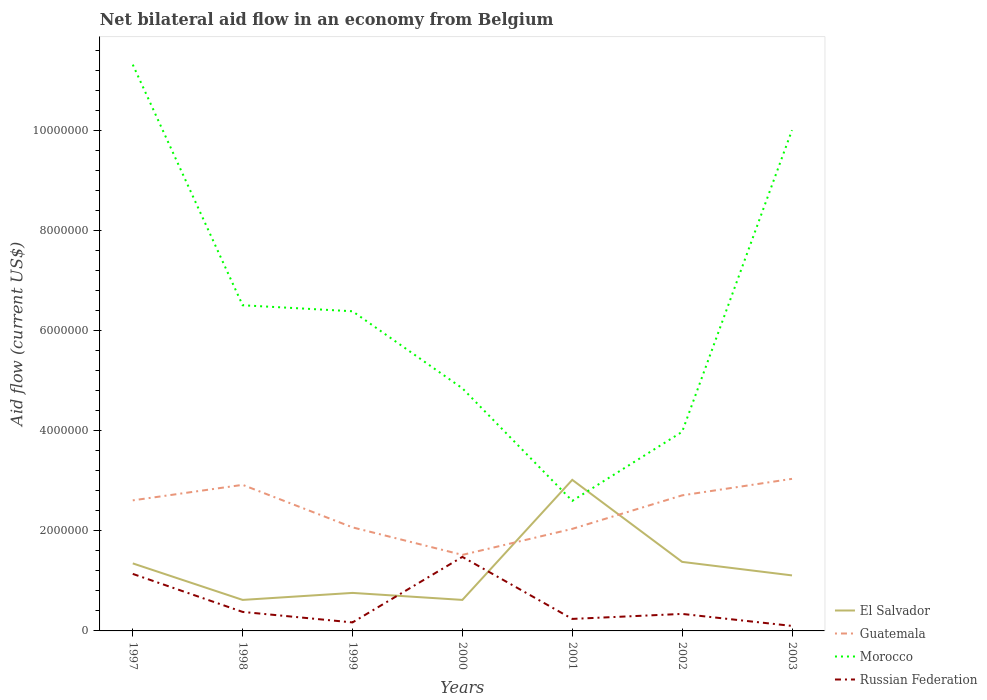Does the line corresponding to El Salvador intersect with the line corresponding to Guatemala?
Give a very brief answer. Yes. Across all years, what is the maximum net bilateral aid flow in El Salvador?
Offer a very short reply. 6.20e+05. What is the total net bilateral aid flow in Morocco in the graph?
Give a very brief answer. 6.47e+06. What is the difference between the highest and the second highest net bilateral aid flow in Morocco?
Keep it short and to the point. 8.72e+06. Is the net bilateral aid flow in Morocco strictly greater than the net bilateral aid flow in El Salvador over the years?
Provide a succinct answer. No. How many lines are there?
Give a very brief answer. 4. Does the graph contain any zero values?
Give a very brief answer. No. Where does the legend appear in the graph?
Give a very brief answer. Bottom right. What is the title of the graph?
Make the answer very short. Net bilateral aid flow in an economy from Belgium. Does "Paraguay" appear as one of the legend labels in the graph?
Your answer should be very brief. No. What is the label or title of the X-axis?
Provide a short and direct response. Years. What is the label or title of the Y-axis?
Make the answer very short. Aid flow (current US$). What is the Aid flow (current US$) in El Salvador in 1997?
Offer a very short reply. 1.35e+06. What is the Aid flow (current US$) of Guatemala in 1997?
Make the answer very short. 2.61e+06. What is the Aid flow (current US$) of Morocco in 1997?
Give a very brief answer. 1.13e+07. What is the Aid flow (current US$) in Russian Federation in 1997?
Give a very brief answer. 1.14e+06. What is the Aid flow (current US$) of El Salvador in 1998?
Give a very brief answer. 6.20e+05. What is the Aid flow (current US$) in Guatemala in 1998?
Keep it short and to the point. 2.92e+06. What is the Aid flow (current US$) of Morocco in 1998?
Keep it short and to the point. 6.51e+06. What is the Aid flow (current US$) in Russian Federation in 1998?
Keep it short and to the point. 3.80e+05. What is the Aid flow (current US$) in El Salvador in 1999?
Give a very brief answer. 7.60e+05. What is the Aid flow (current US$) in Guatemala in 1999?
Provide a succinct answer. 2.07e+06. What is the Aid flow (current US$) of Morocco in 1999?
Give a very brief answer. 6.39e+06. What is the Aid flow (current US$) in El Salvador in 2000?
Ensure brevity in your answer.  6.20e+05. What is the Aid flow (current US$) of Guatemala in 2000?
Provide a succinct answer. 1.52e+06. What is the Aid flow (current US$) in Morocco in 2000?
Make the answer very short. 4.85e+06. What is the Aid flow (current US$) in Russian Federation in 2000?
Your response must be concise. 1.48e+06. What is the Aid flow (current US$) of El Salvador in 2001?
Your answer should be compact. 3.02e+06. What is the Aid flow (current US$) in Guatemala in 2001?
Offer a terse response. 2.04e+06. What is the Aid flow (current US$) in Morocco in 2001?
Keep it short and to the point. 2.60e+06. What is the Aid flow (current US$) in El Salvador in 2002?
Your answer should be very brief. 1.38e+06. What is the Aid flow (current US$) in Guatemala in 2002?
Offer a terse response. 2.71e+06. What is the Aid flow (current US$) of Morocco in 2002?
Provide a succinct answer. 3.98e+06. What is the Aid flow (current US$) of El Salvador in 2003?
Ensure brevity in your answer.  1.11e+06. What is the Aid flow (current US$) of Guatemala in 2003?
Offer a terse response. 3.04e+06. What is the Aid flow (current US$) in Morocco in 2003?
Keep it short and to the point. 1.00e+07. Across all years, what is the maximum Aid flow (current US$) of El Salvador?
Your response must be concise. 3.02e+06. Across all years, what is the maximum Aid flow (current US$) of Guatemala?
Provide a succinct answer. 3.04e+06. Across all years, what is the maximum Aid flow (current US$) of Morocco?
Ensure brevity in your answer.  1.13e+07. Across all years, what is the maximum Aid flow (current US$) of Russian Federation?
Provide a succinct answer. 1.48e+06. Across all years, what is the minimum Aid flow (current US$) in El Salvador?
Provide a succinct answer. 6.20e+05. Across all years, what is the minimum Aid flow (current US$) of Guatemala?
Keep it short and to the point. 1.52e+06. Across all years, what is the minimum Aid flow (current US$) of Morocco?
Make the answer very short. 2.60e+06. Across all years, what is the minimum Aid flow (current US$) in Russian Federation?
Ensure brevity in your answer.  1.00e+05. What is the total Aid flow (current US$) of El Salvador in the graph?
Provide a succinct answer. 8.86e+06. What is the total Aid flow (current US$) of Guatemala in the graph?
Your response must be concise. 1.69e+07. What is the total Aid flow (current US$) in Morocco in the graph?
Ensure brevity in your answer.  4.57e+07. What is the total Aid flow (current US$) in Russian Federation in the graph?
Your answer should be compact. 3.85e+06. What is the difference between the Aid flow (current US$) of El Salvador in 1997 and that in 1998?
Give a very brief answer. 7.30e+05. What is the difference between the Aid flow (current US$) in Guatemala in 1997 and that in 1998?
Give a very brief answer. -3.10e+05. What is the difference between the Aid flow (current US$) of Morocco in 1997 and that in 1998?
Make the answer very short. 4.81e+06. What is the difference between the Aid flow (current US$) of Russian Federation in 1997 and that in 1998?
Ensure brevity in your answer.  7.60e+05. What is the difference between the Aid flow (current US$) of El Salvador in 1997 and that in 1999?
Give a very brief answer. 5.90e+05. What is the difference between the Aid flow (current US$) in Guatemala in 1997 and that in 1999?
Give a very brief answer. 5.40e+05. What is the difference between the Aid flow (current US$) in Morocco in 1997 and that in 1999?
Provide a succinct answer. 4.93e+06. What is the difference between the Aid flow (current US$) in Russian Federation in 1997 and that in 1999?
Offer a terse response. 9.70e+05. What is the difference between the Aid flow (current US$) of El Salvador in 1997 and that in 2000?
Offer a terse response. 7.30e+05. What is the difference between the Aid flow (current US$) in Guatemala in 1997 and that in 2000?
Provide a short and direct response. 1.09e+06. What is the difference between the Aid flow (current US$) in Morocco in 1997 and that in 2000?
Keep it short and to the point. 6.47e+06. What is the difference between the Aid flow (current US$) of El Salvador in 1997 and that in 2001?
Keep it short and to the point. -1.67e+06. What is the difference between the Aid flow (current US$) of Guatemala in 1997 and that in 2001?
Your response must be concise. 5.70e+05. What is the difference between the Aid flow (current US$) of Morocco in 1997 and that in 2001?
Offer a very short reply. 8.72e+06. What is the difference between the Aid flow (current US$) in El Salvador in 1997 and that in 2002?
Your answer should be very brief. -3.00e+04. What is the difference between the Aid flow (current US$) of Guatemala in 1997 and that in 2002?
Make the answer very short. -1.00e+05. What is the difference between the Aid flow (current US$) in Morocco in 1997 and that in 2002?
Your answer should be very brief. 7.34e+06. What is the difference between the Aid flow (current US$) in Russian Federation in 1997 and that in 2002?
Provide a succinct answer. 8.00e+05. What is the difference between the Aid flow (current US$) of El Salvador in 1997 and that in 2003?
Ensure brevity in your answer.  2.40e+05. What is the difference between the Aid flow (current US$) of Guatemala in 1997 and that in 2003?
Offer a very short reply. -4.30e+05. What is the difference between the Aid flow (current US$) of Morocco in 1997 and that in 2003?
Make the answer very short. 1.31e+06. What is the difference between the Aid flow (current US$) in Russian Federation in 1997 and that in 2003?
Make the answer very short. 1.04e+06. What is the difference between the Aid flow (current US$) of Guatemala in 1998 and that in 1999?
Give a very brief answer. 8.50e+05. What is the difference between the Aid flow (current US$) in Guatemala in 1998 and that in 2000?
Offer a terse response. 1.40e+06. What is the difference between the Aid flow (current US$) of Morocco in 1998 and that in 2000?
Your answer should be compact. 1.66e+06. What is the difference between the Aid flow (current US$) in Russian Federation in 1998 and that in 2000?
Offer a very short reply. -1.10e+06. What is the difference between the Aid flow (current US$) of El Salvador in 1998 and that in 2001?
Your answer should be compact. -2.40e+06. What is the difference between the Aid flow (current US$) in Guatemala in 1998 and that in 2001?
Your response must be concise. 8.80e+05. What is the difference between the Aid flow (current US$) of Morocco in 1998 and that in 2001?
Your answer should be very brief. 3.91e+06. What is the difference between the Aid flow (current US$) of Russian Federation in 1998 and that in 2001?
Keep it short and to the point. 1.40e+05. What is the difference between the Aid flow (current US$) in El Salvador in 1998 and that in 2002?
Ensure brevity in your answer.  -7.60e+05. What is the difference between the Aid flow (current US$) in Morocco in 1998 and that in 2002?
Provide a succinct answer. 2.53e+06. What is the difference between the Aid flow (current US$) of El Salvador in 1998 and that in 2003?
Ensure brevity in your answer.  -4.90e+05. What is the difference between the Aid flow (current US$) in Guatemala in 1998 and that in 2003?
Provide a short and direct response. -1.20e+05. What is the difference between the Aid flow (current US$) of Morocco in 1998 and that in 2003?
Your answer should be compact. -3.50e+06. What is the difference between the Aid flow (current US$) in Russian Federation in 1998 and that in 2003?
Your answer should be compact. 2.80e+05. What is the difference between the Aid flow (current US$) in Guatemala in 1999 and that in 2000?
Provide a short and direct response. 5.50e+05. What is the difference between the Aid flow (current US$) of Morocco in 1999 and that in 2000?
Your response must be concise. 1.54e+06. What is the difference between the Aid flow (current US$) in Russian Federation in 1999 and that in 2000?
Give a very brief answer. -1.31e+06. What is the difference between the Aid flow (current US$) of El Salvador in 1999 and that in 2001?
Ensure brevity in your answer.  -2.26e+06. What is the difference between the Aid flow (current US$) of Guatemala in 1999 and that in 2001?
Provide a succinct answer. 3.00e+04. What is the difference between the Aid flow (current US$) in Morocco in 1999 and that in 2001?
Provide a succinct answer. 3.79e+06. What is the difference between the Aid flow (current US$) of Russian Federation in 1999 and that in 2001?
Provide a succinct answer. -7.00e+04. What is the difference between the Aid flow (current US$) of El Salvador in 1999 and that in 2002?
Provide a short and direct response. -6.20e+05. What is the difference between the Aid flow (current US$) of Guatemala in 1999 and that in 2002?
Offer a terse response. -6.40e+05. What is the difference between the Aid flow (current US$) in Morocco in 1999 and that in 2002?
Make the answer very short. 2.41e+06. What is the difference between the Aid flow (current US$) in El Salvador in 1999 and that in 2003?
Keep it short and to the point. -3.50e+05. What is the difference between the Aid flow (current US$) in Guatemala in 1999 and that in 2003?
Ensure brevity in your answer.  -9.70e+05. What is the difference between the Aid flow (current US$) in Morocco in 1999 and that in 2003?
Keep it short and to the point. -3.62e+06. What is the difference between the Aid flow (current US$) in El Salvador in 2000 and that in 2001?
Make the answer very short. -2.40e+06. What is the difference between the Aid flow (current US$) in Guatemala in 2000 and that in 2001?
Your response must be concise. -5.20e+05. What is the difference between the Aid flow (current US$) of Morocco in 2000 and that in 2001?
Provide a succinct answer. 2.25e+06. What is the difference between the Aid flow (current US$) of Russian Federation in 2000 and that in 2001?
Provide a short and direct response. 1.24e+06. What is the difference between the Aid flow (current US$) in El Salvador in 2000 and that in 2002?
Ensure brevity in your answer.  -7.60e+05. What is the difference between the Aid flow (current US$) of Guatemala in 2000 and that in 2002?
Ensure brevity in your answer.  -1.19e+06. What is the difference between the Aid flow (current US$) of Morocco in 2000 and that in 2002?
Ensure brevity in your answer.  8.70e+05. What is the difference between the Aid flow (current US$) in Russian Federation in 2000 and that in 2002?
Your response must be concise. 1.14e+06. What is the difference between the Aid flow (current US$) in El Salvador in 2000 and that in 2003?
Your answer should be very brief. -4.90e+05. What is the difference between the Aid flow (current US$) in Guatemala in 2000 and that in 2003?
Offer a very short reply. -1.52e+06. What is the difference between the Aid flow (current US$) of Morocco in 2000 and that in 2003?
Provide a short and direct response. -5.16e+06. What is the difference between the Aid flow (current US$) in Russian Federation in 2000 and that in 2003?
Provide a short and direct response. 1.38e+06. What is the difference between the Aid flow (current US$) of El Salvador in 2001 and that in 2002?
Offer a terse response. 1.64e+06. What is the difference between the Aid flow (current US$) of Guatemala in 2001 and that in 2002?
Provide a succinct answer. -6.70e+05. What is the difference between the Aid flow (current US$) in Morocco in 2001 and that in 2002?
Offer a very short reply. -1.38e+06. What is the difference between the Aid flow (current US$) of Russian Federation in 2001 and that in 2002?
Give a very brief answer. -1.00e+05. What is the difference between the Aid flow (current US$) of El Salvador in 2001 and that in 2003?
Offer a very short reply. 1.91e+06. What is the difference between the Aid flow (current US$) in Morocco in 2001 and that in 2003?
Make the answer very short. -7.41e+06. What is the difference between the Aid flow (current US$) of Russian Federation in 2001 and that in 2003?
Offer a very short reply. 1.40e+05. What is the difference between the Aid flow (current US$) of El Salvador in 2002 and that in 2003?
Your answer should be compact. 2.70e+05. What is the difference between the Aid flow (current US$) of Guatemala in 2002 and that in 2003?
Provide a short and direct response. -3.30e+05. What is the difference between the Aid flow (current US$) of Morocco in 2002 and that in 2003?
Offer a terse response. -6.03e+06. What is the difference between the Aid flow (current US$) in Russian Federation in 2002 and that in 2003?
Make the answer very short. 2.40e+05. What is the difference between the Aid flow (current US$) of El Salvador in 1997 and the Aid flow (current US$) of Guatemala in 1998?
Provide a short and direct response. -1.57e+06. What is the difference between the Aid flow (current US$) of El Salvador in 1997 and the Aid flow (current US$) of Morocco in 1998?
Your response must be concise. -5.16e+06. What is the difference between the Aid flow (current US$) of El Salvador in 1997 and the Aid flow (current US$) of Russian Federation in 1998?
Your response must be concise. 9.70e+05. What is the difference between the Aid flow (current US$) of Guatemala in 1997 and the Aid flow (current US$) of Morocco in 1998?
Ensure brevity in your answer.  -3.90e+06. What is the difference between the Aid flow (current US$) of Guatemala in 1997 and the Aid flow (current US$) of Russian Federation in 1998?
Provide a short and direct response. 2.23e+06. What is the difference between the Aid flow (current US$) of Morocco in 1997 and the Aid flow (current US$) of Russian Federation in 1998?
Your answer should be very brief. 1.09e+07. What is the difference between the Aid flow (current US$) in El Salvador in 1997 and the Aid flow (current US$) in Guatemala in 1999?
Your answer should be very brief. -7.20e+05. What is the difference between the Aid flow (current US$) of El Salvador in 1997 and the Aid flow (current US$) of Morocco in 1999?
Provide a succinct answer. -5.04e+06. What is the difference between the Aid flow (current US$) in El Salvador in 1997 and the Aid flow (current US$) in Russian Federation in 1999?
Your response must be concise. 1.18e+06. What is the difference between the Aid flow (current US$) in Guatemala in 1997 and the Aid flow (current US$) in Morocco in 1999?
Offer a very short reply. -3.78e+06. What is the difference between the Aid flow (current US$) in Guatemala in 1997 and the Aid flow (current US$) in Russian Federation in 1999?
Your answer should be very brief. 2.44e+06. What is the difference between the Aid flow (current US$) of Morocco in 1997 and the Aid flow (current US$) of Russian Federation in 1999?
Offer a very short reply. 1.12e+07. What is the difference between the Aid flow (current US$) in El Salvador in 1997 and the Aid flow (current US$) in Morocco in 2000?
Your answer should be compact. -3.50e+06. What is the difference between the Aid flow (current US$) in Guatemala in 1997 and the Aid flow (current US$) in Morocco in 2000?
Your response must be concise. -2.24e+06. What is the difference between the Aid flow (current US$) of Guatemala in 1997 and the Aid flow (current US$) of Russian Federation in 2000?
Provide a short and direct response. 1.13e+06. What is the difference between the Aid flow (current US$) of Morocco in 1997 and the Aid flow (current US$) of Russian Federation in 2000?
Your response must be concise. 9.84e+06. What is the difference between the Aid flow (current US$) in El Salvador in 1997 and the Aid flow (current US$) in Guatemala in 2001?
Offer a very short reply. -6.90e+05. What is the difference between the Aid flow (current US$) in El Salvador in 1997 and the Aid flow (current US$) in Morocco in 2001?
Give a very brief answer. -1.25e+06. What is the difference between the Aid flow (current US$) of El Salvador in 1997 and the Aid flow (current US$) of Russian Federation in 2001?
Give a very brief answer. 1.11e+06. What is the difference between the Aid flow (current US$) of Guatemala in 1997 and the Aid flow (current US$) of Morocco in 2001?
Give a very brief answer. 10000. What is the difference between the Aid flow (current US$) of Guatemala in 1997 and the Aid flow (current US$) of Russian Federation in 2001?
Your answer should be very brief. 2.37e+06. What is the difference between the Aid flow (current US$) in Morocco in 1997 and the Aid flow (current US$) in Russian Federation in 2001?
Provide a succinct answer. 1.11e+07. What is the difference between the Aid flow (current US$) in El Salvador in 1997 and the Aid flow (current US$) in Guatemala in 2002?
Offer a terse response. -1.36e+06. What is the difference between the Aid flow (current US$) of El Salvador in 1997 and the Aid flow (current US$) of Morocco in 2002?
Give a very brief answer. -2.63e+06. What is the difference between the Aid flow (current US$) in El Salvador in 1997 and the Aid flow (current US$) in Russian Federation in 2002?
Make the answer very short. 1.01e+06. What is the difference between the Aid flow (current US$) of Guatemala in 1997 and the Aid flow (current US$) of Morocco in 2002?
Give a very brief answer. -1.37e+06. What is the difference between the Aid flow (current US$) in Guatemala in 1997 and the Aid flow (current US$) in Russian Federation in 2002?
Provide a succinct answer. 2.27e+06. What is the difference between the Aid flow (current US$) in Morocco in 1997 and the Aid flow (current US$) in Russian Federation in 2002?
Give a very brief answer. 1.10e+07. What is the difference between the Aid flow (current US$) in El Salvador in 1997 and the Aid flow (current US$) in Guatemala in 2003?
Offer a very short reply. -1.69e+06. What is the difference between the Aid flow (current US$) of El Salvador in 1997 and the Aid flow (current US$) of Morocco in 2003?
Ensure brevity in your answer.  -8.66e+06. What is the difference between the Aid flow (current US$) of El Salvador in 1997 and the Aid flow (current US$) of Russian Federation in 2003?
Ensure brevity in your answer.  1.25e+06. What is the difference between the Aid flow (current US$) of Guatemala in 1997 and the Aid flow (current US$) of Morocco in 2003?
Ensure brevity in your answer.  -7.40e+06. What is the difference between the Aid flow (current US$) in Guatemala in 1997 and the Aid flow (current US$) in Russian Federation in 2003?
Provide a short and direct response. 2.51e+06. What is the difference between the Aid flow (current US$) of Morocco in 1997 and the Aid flow (current US$) of Russian Federation in 2003?
Offer a very short reply. 1.12e+07. What is the difference between the Aid flow (current US$) in El Salvador in 1998 and the Aid flow (current US$) in Guatemala in 1999?
Give a very brief answer. -1.45e+06. What is the difference between the Aid flow (current US$) of El Salvador in 1998 and the Aid flow (current US$) of Morocco in 1999?
Ensure brevity in your answer.  -5.77e+06. What is the difference between the Aid flow (current US$) of El Salvador in 1998 and the Aid flow (current US$) of Russian Federation in 1999?
Ensure brevity in your answer.  4.50e+05. What is the difference between the Aid flow (current US$) of Guatemala in 1998 and the Aid flow (current US$) of Morocco in 1999?
Make the answer very short. -3.47e+06. What is the difference between the Aid flow (current US$) in Guatemala in 1998 and the Aid flow (current US$) in Russian Federation in 1999?
Your response must be concise. 2.75e+06. What is the difference between the Aid flow (current US$) in Morocco in 1998 and the Aid flow (current US$) in Russian Federation in 1999?
Your response must be concise. 6.34e+06. What is the difference between the Aid flow (current US$) of El Salvador in 1998 and the Aid flow (current US$) of Guatemala in 2000?
Make the answer very short. -9.00e+05. What is the difference between the Aid flow (current US$) in El Salvador in 1998 and the Aid flow (current US$) in Morocco in 2000?
Your answer should be compact. -4.23e+06. What is the difference between the Aid flow (current US$) of El Salvador in 1998 and the Aid flow (current US$) of Russian Federation in 2000?
Provide a short and direct response. -8.60e+05. What is the difference between the Aid flow (current US$) in Guatemala in 1998 and the Aid flow (current US$) in Morocco in 2000?
Make the answer very short. -1.93e+06. What is the difference between the Aid flow (current US$) of Guatemala in 1998 and the Aid flow (current US$) of Russian Federation in 2000?
Provide a short and direct response. 1.44e+06. What is the difference between the Aid flow (current US$) of Morocco in 1998 and the Aid flow (current US$) of Russian Federation in 2000?
Your answer should be very brief. 5.03e+06. What is the difference between the Aid flow (current US$) in El Salvador in 1998 and the Aid flow (current US$) in Guatemala in 2001?
Your answer should be compact. -1.42e+06. What is the difference between the Aid flow (current US$) of El Salvador in 1998 and the Aid flow (current US$) of Morocco in 2001?
Make the answer very short. -1.98e+06. What is the difference between the Aid flow (current US$) in Guatemala in 1998 and the Aid flow (current US$) in Morocco in 2001?
Your answer should be compact. 3.20e+05. What is the difference between the Aid flow (current US$) in Guatemala in 1998 and the Aid flow (current US$) in Russian Federation in 2001?
Your response must be concise. 2.68e+06. What is the difference between the Aid flow (current US$) of Morocco in 1998 and the Aid flow (current US$) of Russian Federation in 2001?
Offer a very short reply. 6.27e+06. What is the difference between the Aid flow (current US$) of El Salvador in 1998 and the Aid flow (current US$) of Guatemala in 2002?
Provide a short and direct response. -2.09e+06. What is the difference between the Aid flow (current US$) of El Salvador in 1998 and the Aid flow (current US$) of Morocco in 2002?
Your response must be concise. -3.36e+06. What is the difference between the Aid flow (current US$) of Guatemala in 1998 and the Aid flow (current US$) of Morocco in 2002?
Make the answer very short. -1.06e+06. What is the difference between the Aid flow (current US$) in Guatemala in 1998 and the Aid flow (current US$) in Russian Federation in 2002?
Keep it short and to the point. 2.58e+06. What is the difference between the Aid flow (current US$) of Morocco in 1998 and the Aid flow (current US$) of Russian Federation in 2002?
Your response must be concise. 6.17e+06. What is the difference between the Aid flow (current US$) in El Salvador in 1998 and the Aid flow (current US$) in Guatemala in 2003?
Keep it short and to the point. -2.42e+06. What is the difference between the Aid flow (current US$) in El Salvador in 1998 and the Aid flow (current US$) in Morocco in 2003?
Offer a very short reply. -9.39e+06. What is the difference between the Aid flow (current US$) of El Salvador in 1998 and the Aid flow (current US$) of Russian Federation in 2003?
Make the answer very short. 5.20e+05. What is the difference between the Aid flow (current US$) in Guatemala in 1998 and the Aid flow (current US$) in Morocco in 2003?
Your answer should be very brief. -7.09e+06. What is the difference between the Aid flow (current US$) of Guatemala in 1998 and the Aid flow (current US$) of Russian Federation in 2003?
Your answer should be compact. 2.82e+06. What is the difference between the Aid flow (current US$) in Morocco in 1998 and the Aid flow (current US$) in Russian Federation in 2003?
Make the answer very short. 6.41e+06. What is the difference between the Aid flow (current US$) of El Salvador in 1999 and the Aid flow (current US$) of Guatemala in 2000?
Make the answer very short. -7.60e+05. What is the difference between the Aid flow (current US$) of El Salvador in 1999 and the Aid flow (current US$) of Morocco in 2000?
Your answer should be very brief. -4.09e+06. What is the difference between the Aid flow (current US$) in El Salvador in 1999 and the Aid flow (current US$) in Russian Federation in 2000?
Offer a terse response. -7.20e+05. What is the difference between the Aid flow (current US$) in Guatemala in 1999 and the Aid flow (current US$) in Morocco in 2000?
Provide a short and direct response. -2.78e+06. What is the difference between the Aid flow (current US$) of Guatemala in 1999 and the Aid flow (current US$) of Russian Federation in 2000?
Your response must be concise. 5.90e+05. What is the difference between the Aid flow (current US$) of Morocco in 1999 and the Aid flow (current US$) of Russian Federation in 2000?
Give a very brief answer. 4.91e+06. What is the difference between the Aid flow (current US$) in El Salvador in 1999 and the Aid flow (current US$) in Guatemala in 2001?
Your answer should be compact. -1.28e+06. What is the difference between the Aid flow (current US$) in El Salvador in 1999 and the Aid flow (current US$) in Morocco in 2001?
Give a very brief answer. -1.84e+06. What is the difference between the Aid flow (current US$) in El Salvador in 1999 and the Aid flow (current US$) in Russian Federation in 2001?
Give a very brief answer. 5.20e+05. What is the difference between the Aid flow (current US$) of Guatemala in 1999 and the Aid flow (current US$) of Morocco in 2001?
Give a very brief answer. -5.30e+05. What is the difference between the Aid flow (current US$) of Guatemala in 1999 and the Aid flow (current US$) of Russian Federation in 2001?
Provide a succinct answer. 1.83e+06. What is the difference between the Aid flow (current US$) in Morocco in 1999 and the Aid flow (current US$) in Russian Federation in 2001?
Your answer should be compact. 6.15e+06. What is the difference between the Aid flow (current US$) of El Salvador in 1999 and the Aid flow (current US$) of Guatemala in 2002?
Provide a succinct answer. -1.95e+06. What is the difference between the Aid flow (current US$) in El Salvador in 1999 and the Aid flow (current US$) in Morocco in 2002?
Your response must be concise. -3.22e+06. What is the difference between the Aid flow (current US$) of El Salvador in 1999 and the Aid flow (current US$) of Russian Federation in 2002?
Provide a short and direct response. 4.20e+05. What is the difference between the Aid flow (current US$) in Guatemala in 1999 and the Aid flow (current US$) in Morocco in 2002?
Keep it short and to the point. -1.91e+06. What is the difference between the Aid flow (current US$) of Guatemala in 1999 and the Aid flow (current US$) of Russian Federation in 2002?
Keep it short and to the point. 1.73e+06. What is the difference between the Aid flow (current US$) of Morocco in 1999 and the Aid flow (current US$) of Russian Federation in 2002?
Ensure brevity in your answer.  6.05e+06. What is the difference between the Aid flow (current US$) in El Salvador in 1999 and the Aid flow (current US$) in Guatemala in 2003?
Provide a short and direct response. -2.28e+06. What is the difference between the Aid flow (current US$) of El Salvador in 1999 and the Aid flow (current US$) of Morocco in 2003?
Offer a terse response. -9.25e+06. What is the difference between the Aid flow (current US$) in Guatemala in 1999 and the Aid flow (current US$) in Morocco in 2003?
Provide a short and direct response. -7.94e+06. What is the difference between the Aid flow (current US$) in Guatemala in 1999 and the Aid flow (current US$) in Russian Federation in 2003?
Keep it short and to the point. 1.97e+06. What is the difference between the Aid flow (current US$) of Morocco in 1999 and the Aid flow (current US$) of Russian Federation in 2003?
Your answer should be compact. 6.29e+06. What is the difference between the Aid flow (current US$) of El Salvador in 2000 and the Aid flow (current US$) of Guatemala in 2001?
Keep it short and to the point. -1.42e+06. What is the difference between the Aid flow (current US$) of El Salvador in 2000 and the Aid flow (current US$) of Morocco in 2001?
Your answer should be very brief. -1.98e+06. What is the difference between the Aid flow (current US$) of Guatemala in 2000 and the Aid flow (current US$) of Morocco in 2001?
Ensure brevity in your answer.  -1.08e+06. What is the difference between the Aid flow (current US$) of Guatemala in 2000 and the Aid flow (current US$) of Russian Federation in 2001?
Your answer should be compact. 1.28e+06. What is the difference between the Aid flow (current US$) in Morocco in 2000 and the Aid flow (current US$) in Russian Federation in 2001?
Your answer should be compact. 4.61e+06. What is the difference between the Aid flow (current US$) in El Salvador in 2000 and the Aid flow (current US$) in Guatemala in 2002?
Ensure brevity in your answer.  -2.09e+06. What is the difference between the Aid flow (current US$) of El Salvador in 2000 and the Aid flow (current US$) of Morocco in 2002?
Offer a very short reply. -3.36e+06. What is the difference between the Aid flow (current US$) in Guatemala in 2000 and the Aid flow (current US$) in Morocco in 2002?
Keep it short and to the point. -2.46e+06. What is the difference between the Aid flow (current US$) in Guatemala in 2000 and the Aid flow (current US$) in Russian Federation in 2002?
Offer a terse response. 1.18e+06. What is the difference between the Aid flow (current US$) in Morocco in 2000 and the Aid flow (current US$) in Russian Federation in 2002?
Your answer should be compact. 4.51e+06. What is the difference between the Aid flow (current US$) of El Salvador in 2000 and the Aid flow (current US$) of Guatemala in 2003?
Ensure brevity in your answer.  -2.42e+06. What is the difference between the Aid flow (current US$) in El Salvador in 2000 and the Aid flow (current US$) in Morocco in 2003?
Keep it short and to the point. -9.39e+06. What is the difference between the Aid flow (current US$) of El Salvador in 2000 and the Aid flow (current US$) of Russian Federation in 2003?
Offer a terse response. 5.20e+05. What is the difference between the Aid flow (current US$) of Guatemala in 2000 and the Aid flow (current US$) of Morocco in 2003?
Your answer should be very brief. -8.49e+06. What is the difference between the Aid flow (current US$) of Guatemala in 2000 and the Aid flow (current US$) of Russian Federation in 2003?
Your answer should be compact. 1.42e+06. What is the difference between the Aid flow (current US$) in Morocco in 2000 and the Aid flow (current US$) in Russian Federation in 2003?
Your answer should be very brief. 4.75e+06. What is the difference between the Aid flow (current US$) of El Salvador in 2001 and the Aid flow (current US$) of Guatemala in 2002?
Your answer should be very brief. 3.10e+05. What is the difference between the Aid flow (current US$) of El Salvador in 2001 and the Aid flow (current US$) of Morocco in 2002?
Provide a short and direct response. -9.60e+05. What is the difference between the Aid flow (current US$) in El Salvador in 2001 and the Aid flow (current US$) in Russian Federation in 2002?
Your response must be concise. 2.68e+06. What is the difference between the Aid flow (current US$) of Guatemala in 2001 and the Aid flow (current US$) of Morocco in 2002?
Keep it short and to the point. -1.94e+06. What is the difference between the Aid flow (current US$) in Guatemala in 2001 and the Aid flow (current US$) in Russian Federation in 2002?
Your response must be concise. 1.70e+06. What is the difference between the Aid flow (current US$) in Morocco in 2001 and the Aid flow (current US$) in Russian Federation in 2002?
Provide a short and direct response. 2.26e+06. What is the difference between the Aid flow (current US$) of El Salvador in 2001 and the Aid flow (current US$) of Guatemala in 2003?
Your answer should be compact. -2.00e+04. What is the difference between the Aid flow (current US$) of El Salvador in 2001 and the Aid flow (current US$) of Morocco in 2003?
Keep it short and to the point. -6.99e+06. What is the difference between the Aid flow (current US$) in El Salvador in 2001 and the Aid flow (current US$) in Russian Federation in 2003?
Your response must be concise. 2.92e+06. What is the difference between the Aid flow (current US$) in Guatemala in 2001 and the Aid flow (current US$) in Morocco in 2003?
Your answer should be compact. -7.97e+06. What is the difference between the Aid flow (current US$) of Guatemala in 2001 and the Aid flow (current US$) of Russian Federation in 2003?
Offer a terse response. 1.94e+06. What is the difference between the Aid flow (current US$) of Morocco in 2001 and the Aid flow (current US$) of Russian Federation in 2003?
Make the answer very short. 2.50e+06. What is the difference between the Aid flow (current US$) in El Salvador in 2002 and the Aid flow (current US$) in Guatemala in 2003?
Your answer should be compact. -1.66e+06. What is the difference between the Aid flow (current US$) in El Salvador in 2002 and the Aid flow (current US$) in Morocco in 2003?
Ensure brevity in your answer.  -8.63e+06. What is the difference between the Aid flow (current US$) in El Salvador in 2002 and the Aid flow (current US$) in Russian Federation in 2003?
Offer a terse response. 1.28e+06. What is the difference between the Aid flow (current US$) of Guatemala in 2002 and the Aid flow (current US$) of Morocco in 2003?
Ensure brevity in your answer.  -7.30e+06. What is the difference between the Aid flow (current US$) in Guatemala in 2002 and the Aid flow (current US$) in Russian Federation in 2003?
Give a very brief answer. 2.61e+06. What is the difference between the Aid flow (current US$) of Morocco in 2002 and the Aid flow (current US$) of Russian Federation in 2003?
Your answer should be compact. 3.88e+06. What is the average Aid flow (current US$) of El Salvador per year?
Provide a short and direct response. 1.27e+06. What is the average Aid flow (current US$) of Guatemala per year?
Ensure brevity in your answer.  2.42e+06. What is the average Aid flow (current US$) of Morocco per year?
Make the answer very short. 6.52e+06. In the year 1997, what is the difference between the Aid flow (current US$) of El Salvador and Aid flow (current US$) of Guatemala?
Provide a succinct answer. -1.26e+06. In the year 1997, what is the difference between the Aid flow (current US$) in El Salvador and Aid flow (current US$) in Morocco?
Your response must be concise. -9.97e+06. In the year 1997, what is the difference between the Aid flow (current US$) in Guatemala and Aid flow (current US$) in Morocco?
Provide a succinct answer. -8.71e+06. In the year 1997, what is the difference between the Aid flow (current US$) of Guatemala and Aid flow (current US$) of Russian Federation?
Your response must be concise. 1.47e+06. In the year 1997, what is the difference between the Aid flow (current US$) of Morocco and Aid flow (current US$) of Russian Federation?
Your answer should be compact. 1.02e+07. In the year 1998, what is the difference between the Aid flow (current US$) in El Salvador and Aid flow (current US$) in Guatemala?
Provide a short and direct response. -2.30e+06. In the year 1998, what is the difference between the Aid flow (current US$) of El Salvador and Aid flow (current US$) of Morocco?
Your response must be concise. -5.89e+06. In the year 1998, what is the difference between the Aid flow (current US$) of El Salvador and Aid flow (current US$) of Russian Federation?
Make the answer very short. 2.40e+05. In the year 1998, what is the difference between the Aid flow (current US$) in Guatemala and Aid flow (current US$) in Morocco?
Your answer should be compact. -3.59e+06. In the year 1998, what is the difference between the Aid flow (current US$) in Guatemala and Aid flow (current US$) in Russian Federation?
Offer a terse response. 2.54e+06. In the year 1998, what is the difference between the Aid flow (current US$) of Morocco and Aid flow (current US$) of Russian Federation?
Keep it short and to the point. 6.13e+06. In the year 1999, what is the difference between the Aid flow (current US$) of El Salvador and Aid flow (current US$) of Guatemala?
Provide a succinct answer. -1.31e+06. In the year 1999, what is the difference between the Aid flow (current US$) in El Salvador and Aid flow (current US$) in Morocco?
Make the answer very short. -5.63e+06. In the year 1999, what is the difference between the Aid flow (current US$) in El Salvador and Aid flow (current US$) in Russian Federation?
Your answer should be very brief. 5.90e+05. In the year 1999, what is the difference between the Aid flow (current US$) of Guatemala and Aid flow (current US$) of Morocco?
Offer a terse response. -4.32e+06. In the year 1999, what is the difference between the Aid flow (current US$) of Guatemala and Aid flow (current US$) of Russian Federation?
Ensure brevity in your answer.  1.90e+06. In the year 1999, what is the difference between the Aid flow (current US$) of Morocco and Aid flow (current US$) of Russian Federation?
Provide a succinct answer. 6.22e+06. In the year 2000, what is the difference between the Aid flow (current US$) of El Salvador and Aid flow (current US$) of Guatemala?
Make the answer very short. -9.00e+05. In the year 2000, what is the difference between the Aid flow (current US$) in El Salvador and Aid flow (current US$) in Morocco?
Your answer should be compact. -4.23e+06. In the year 2000, what is the difference between the Aid flow (current US$) in El Salvador and Aid flow (current US$) in Russian Federation?
Your answer should be very brief. -8.60e+05. In the year 2000, what is the difference between the Aid flow (current US$) in Guatemala and Aid flow (current US$) in Morocco?
Keep it short and to the point. -3.33e+06. In the year 2000, what is the difference between the Aid flow (current US$) of Guatemala and Aid flow (current US$) of Russian Federation?
Offer a terse response. 4.00e+04. In the year 2000, what is the difference between the Aid flow (current US$) in Morocco and Aid flow (current US$) in Russian Federation?
Provide a succinct answer. 3.37e+06. In the year 2001, what is the difference between the Aid flow (current US$) of El Salvador and Aid flow (current US$) of Guatemala?
Offer a terse response. 9.80e+05. In the year 2001, what is the difference between the Aid flow (current US$) of El Salvador and Aid flow (current US$) of Morocco?
Provide a succinct answer. 4.20e+05. In the year 2001, what is the difference between the Aid flow (current US$) of El Salvador and Aid flow (current US$) of Russian Federation?
Offer a terse response. 2.78e+06. In the year 2001, what is the difference between the Aid flow (current US$) of Guatemala and Aid flow (current US$) of Morocco?
Your response must be concise. -5.60e+05. In the year 2001, what is the difference between the Aid flow (current US$) of Guatemala and Aid flow (current US$) of Russian Federation?
Give a very brief answer. 1.80e+06. In the year 2001, what is the difference between the Aid flow (current US$) in Morocco and Aid flow (current US$) in Russian Federation?
Make the answer very short. 2.36e+06. In the year 2002, what is the difference between the Aid flow (current US$) in El Salvador and Aid flow (current US$) in Guatemala?
Offer a very short reply. -1.33e+06. In the year 2002, what is the difference between the Aid flow (current US$) in El Salvador and Aid flow (current US$) in Morocco?
Your answer should be compact. -2.60e+06. In the year 2002, what is the difference between the Aid flow (current US$) of El Salvador and Aid flow (current US$) of Russian Federation?
Offer a very short reply. 1.04e+06. In the year 2002, what is the difference between the Aid flow (current US$) of Guatemala and Aid flow (current US$) of Morocco?
Your response must be concise. -1.27e+06. In the year 2002, what is the difference between the Aid flow (current US$) in Guatemala and Aid flow (current US$) in Russian Federation?
Your response must be concise. 2.37e+06. In the year 2002, what is the difference between the Aid flow (current US$) in Morocco and Aid flow (current US$) in Russian Federation?
Make the answer very short. 3.64e+06. In the year 2003, what is the difference between the Aid flow (current US$) of El Salvador and Aid flow (current US$) of Guatemala?
Your response must be concise. -1.93e+06. In the year 2003, what is the difference between the Aid flow (current US$) in El Salvador and Aid flow (current US$) in Morocco?
Provide a succinct answer. -8.90e+06. In the year 2003, what is the difference between the Aid flow (current US$) in El Salvador and Aid flow (current US$) in Russian Federation?
Your response must be concise. 1.01e+06. In the year 2003, what is the difference between the Aid flow (current US$) in Guatemala and Aid flow (current US$) in Morocco?
Give a very brief answer. -6.97e+06. In the year 2003, what is the difference between the Aid flow (current US$) of Guatemala and Aid flow (current US$) of Russian Federation?
Provide a succinct answer. 2.94e+06. In the year 2003, what is the difference between the Aid flow (current US$) in Morocco and Aid flow (current US$) in Russian Federation?
Your response must be concise. 9.91e+06. What is the ratio of the Aid flow (current US$) of El Salvador in 1997 to that in 1998?
Ensure brevity in your answer.  2.18. What is the ratio of the Aid flow (current US$) of Guatemala in 1997 to that in 1998?
Offer a very short reply. 0.89. What is the ratio of the Aid flow (current US$) in Morocco in 1997 to that in 1998?
Your answer should be very brief. 1.74. What is the ratio of the Aid flow (current US$) in Russian Federation in 1997 to that in 1998?
Provide a short and direct response. 3. What is the ratio of the Aid flow (current US$) in El Salvador in 1997 to that in 1999?
Offer a terse response. 1.78. What is the ratio of the Aid flow (current US$) in Guatemala in 1997 to that in 1999?
Your answer should be compact. 1.26. What is the ratio of the Aid flow (current US$) of Morocco in 1997 to that in 1999?
Keep it short and to the point. 1.77. What is the ratio of the Aid flow (current US$) of Russian Federation in 1997 to that in 1999?
Your answer should be very brief. 6.71. What is the ratio of the Aid flow (current US$) of El Salvador in 1997 to that in 2000?
Ensure brevity in your answer.  2.18. What is the ratio of the Aid flow (current US$) in Guatemala in 1997 to that in 2000?
Keep it short and to the point. 1.72. What is the ratio of the Aid flow (current US$) in Morocco in 1997 to that in 2000?
Keep it short and to the point. 2.33. What is the ratio of the Aid flow (current US$) of Russian Federation in 1997 to that in 2000?
Your response must be concise. 0.77. What is the ratio of the Aid flow (current US$) of El Salvador in 1997 to that in 2001?
Your response must be concise. 0.45. What is the ratio of the Aid flow (current US$) of Guatemala in 1997 to that in 2001?
Your response must be concise. 1.28. What is the ratio of the Aid flow (current US$) in Morocco in 1997 to that in 2001?
Your answer should be very brief. 4.35. What is the ratio of the Aid flow (current US$) in Russian Federation in 1997 to that in 2001?
Your response must be concise. 4.75. What is the ratio of the Aid flow (current US$) in El Salvador in 1997 to that in 2002?
Offer a terse response. 0.98. What is the ratio of the Aid flow (current US$) of Guatemala in 1997 to that in 2002?
Your answer should be compact. 0.96. What is the ratio of the Aid flow (current US$) of Morocco in 1997 to that in 2002?
Your answer should be very brief. 2.84. What is the ratio of the Aid flow (current US$) of Russian Federation in 1997 to that in 2002?
Offer a terse response. 3.35. What is the ratio of the Aid flow (current US$) of El Salvador in 1997 to that in 2003?
Give a very brief answer. 1.22. What is the ratio of the Aid flow (current US$) in Guatemala in 1997 to that in 2003?
Give a very brief answer. 0.86. What is the ratio of the Aid flow (current US$) in Morocco in 1997 to that in 2003?
Make the answer very short. 1.13. What is the ratio of the Aid flow (current US$) of Russian Federation in 1997 to that in 2003?
Keep it short and to the point. 11.4. What is the ratio of the Aid flow (current US$) in El Salvador in 1998 to that in 1999?
Your answer should be compact. 0.82. What is the ratio of the Aid flow (current US$) in Guatemala in 1998 to that in 1999?
Give a very brief answer. 1.41. What is the ratio of the Aid flow (current US$) of Morocco in 1998 to that in 1999?
Your answer should be compact. 1.02. What is the ratio of the Aid flow (current US$) of Russian Federation in 1998 to that in 1999?
Ensure brevity in your answer.  2.24. What is the ratio of the Aid flow (current US$) in Guatemala in 1998 to that in 2000?
Provide a short and direct response. 1.92. What is the ratio of the Aid flow (current US$) of Morocco in 1998 to that in 2000?
Offer a terse response. 1.34. What is the ratio of the Aid flow (current US$) in Russian Federation in 1998 to that in 2000?
Provide a short and direct response. 0.26. What is the ratio of the Aid flow (current US$) of El Salvador in 1998 to that in 2001?
Give a very brief answer. 0.21. What is the ratio of the Aid flow (current US$) of Guatemala in 1998 to that in 2001?
Make the answer very short. 1.43. What is the ratio of the Aid flow (current US$) of Morocco in 1998 to that in 2001?
Your answer should be very brief. 2.5. What is the ratio of the Aid flow (current US$) of Russian Federation in 1998 to that in 2001?
Offer a terse response. 1.58. What is the ratio of the Aid flow (current US$) of El Salvador in 1998 to that in 2002?
Your response must be concise. 0.45. What is the ratio of the Aid flow (current US$) in Guatemala in 1998 to that in 2002?
Offer a very short reply. 1.08. What is the ratio of the Aid flow (current US$) of Morocco in 1998 to that in 2002?
Provide a short and direct response. 1.64. What is the ratio of the Aid flow (current US$) of Russian Federation in 1998 to that in 2002?
Your answer should be very brief. 1.12. What is the ratio of the Aid flow (current US$) in El Salvador in 1998 to that in 2003?
Your response must be concise. 0.56. What is the ratio of the Aid flow (current US$) in Guatemala in 1998 to that in 2003?
Make the answer very short. 0.96. What is the ratio of the Aid flow (current US$) of Morocco in 1998 to that in 2003?
Offer a terse response. 0.65. What is the ratio of the Aid flow (current US$) in El Salvador in 1999 to that in 2000?
Your response must be concise. 1.23. What is the ratio of the Aid flow (current US$) of Guatemala in 1999 to that in 2000?
Your answer should be compact. 1.36. What is the ratio of the Aid flow (current US$) in Morocco in 1999 to that in 2000?
Provide a succinct answer. 1.32. What is the ratio of the Aid flow (current US$) of Russian Federation in 1999 to that in 2000?
Provide a short and direct response. 0.11. What is the ratio of the Aid flow (current US$) of El Salvador in 1999 to that in 2001?
Give a very brief answer. 0.25. What is the ratio of the Aid flow (current US$) in Guatemala in 1999 to that in 2001?
Provide a short and direct response. 1.01. What is the ratio of the Aid flow (current US$) of Morocco in 1999 to that in 2001?
Ensure brevity in your answer.  2.46. What is the ratio of the Aid flow (current US$) of Russian Federation in 1999 to that in 2001?
Provide a short and direct response. 0.71. What is the ratio of the Aid flow (current US$) in El Salvador in 1999 to that in 2002?
Keep it short and to the point. 0.55. What is the ratio of the Aid flow (current US$) in Guatemala in 1999 to that in 2002?
Provide a short and direct response. 0.76. What is the ratio of the Aid flow (current US$) of Morocco in 1999 to that in 2002?
Your answer should be very brief. 1.61. What is the ratio of the Aid flow (current US$) in El Salvador in 1999 to that in 2003?
Provide a succinct answer. 0.68. What is the ratio of the Aid flow (current US$) of Guatemala in 1999 to that in 2003?
Offer a terse response. 0.68. What is the ratio of the Aid flow (current US$) of Morocco in 1999 to that in 2003?
Give a very brief answer. 0.64. What is the ratio of the Aid flow (current US$) in Russian Federation in 1999 to that in 2003?
Make the answer very short. 1.7. What is the ratio of the Aid flow (current US$) in El Salvador in 2000 to that in 2001?
Provide a short and direct response. 0.21. What is the ratio of the Aid flow (current US$) of Guatemala in 2000 to that in 2001?
Keep it short and to the point. 0.75. What is the ratio of the Aid flow (current US$) in Morocco in 2000 to that in 2001?
Your answer should be very brief. 1.87. What is the ratio of the Aid flow (current US$) in Russian Federation in 2000 to that in 2001?
Give a very brief answer. 6.17. What is the ratio of the Aid flow (current US$) of El Salvador in 2000 to that in 2002?
Keep it short and to the point. 0.45. What is the ratio of the Aid flow (current US$) in Guatemala in 2000 to that in 2002?
Offer a very short reply. 0.56. What is the ratio of the Aid flow (current US$) in Morocco in 2000 to that in 2002?
Your answer should be compact. 1.22. What is the ratio of the Aid flow (current US$) of Russian Federation in 2000 to that in 2002?
Ensure brevity in your answer.  4.35. What is the ratio of the Aid flow (current US$) of El Salvador in 2000 to that in 2003?
Provide a short and direct response. 0.56. What is the ratio of the Aid flow (current US$) of Morocco in 2000 to that in 2003?
Give a very brief answer. 0.48. What is the ratio of the Aid flow (current US$) in Russian Federation in 2000 to that in 2003?
Provide a short and direct response. 14.8. What is the ratio of the Aid flow (current US$) of El Salvador in 2001 to that in 2002?
Keep it short and to the point. 2.19. What is the ratio of the Aid flow (current US$) of Guatemala in 2001 to that in 2002?
Ensure brevity in your answer.  0.75. What is the ratio of the Aid flow (current US$) in Morocco in 2001 to that in 2002?
Make the answer very short. 0.65. What is the ratio of the Aid flow (current US$) in Russian Federation in 2001 to that in 2002?
Offer a very short reply. 0.71. What is the ratio of the Aid flow (current US$) in El Salvador in 2001 to that in 2003?
Keep it short and to the point. 2.72. What is the ratio of the Aid flow (current US$) in Guatemala in 2001 to that in 2003?
Make the answer very short. 0.67. What is the ratio of the Aid flow (current US$) in Morocco in 2001 to that in 2003?
Keep it short and to the point. 0.26. What is the ratio of the Aid flow (current US$) in El Salvador in 2002 to that in 2003?
Your answer should be compact. 1.24. What is the ratio of the Aid flow (current US$) of Guatemala in 2002 to that in 2003?
Your answer should be compact. 0.89. What is the ratio of the Aid flow (current US$) in Morocco in 2002 to that in 2003?
Provide a succinct answer. 0.4. What is the difference between the highest and the second highest Aid flow (current US$) of El Salvador?
Make the answer very short. 1.64e+06. What is the difference between the highest and the second highest Aid flow (current US$) in Morocco?
Provide a succinct answer. 1.31e+06. What is the difference between the highest and the lowest Aid flow (current US$) in El Salvador?
Your answer should be very brief. 2.40e+06. What is the difference between the highest and the lowest Aid flow (current US$) of Guatemala?
Your answer should be very brief. 1.52e+06. What is the difference between the highest and the lowest Aid flow (current US$) in Morocco?
Provide a succinct answer. 8.72e+06. What is the difference between the highest and the lowest Aid flow (current US$) of Russian Federation?
Your response must be concise. 1.38e+06. 